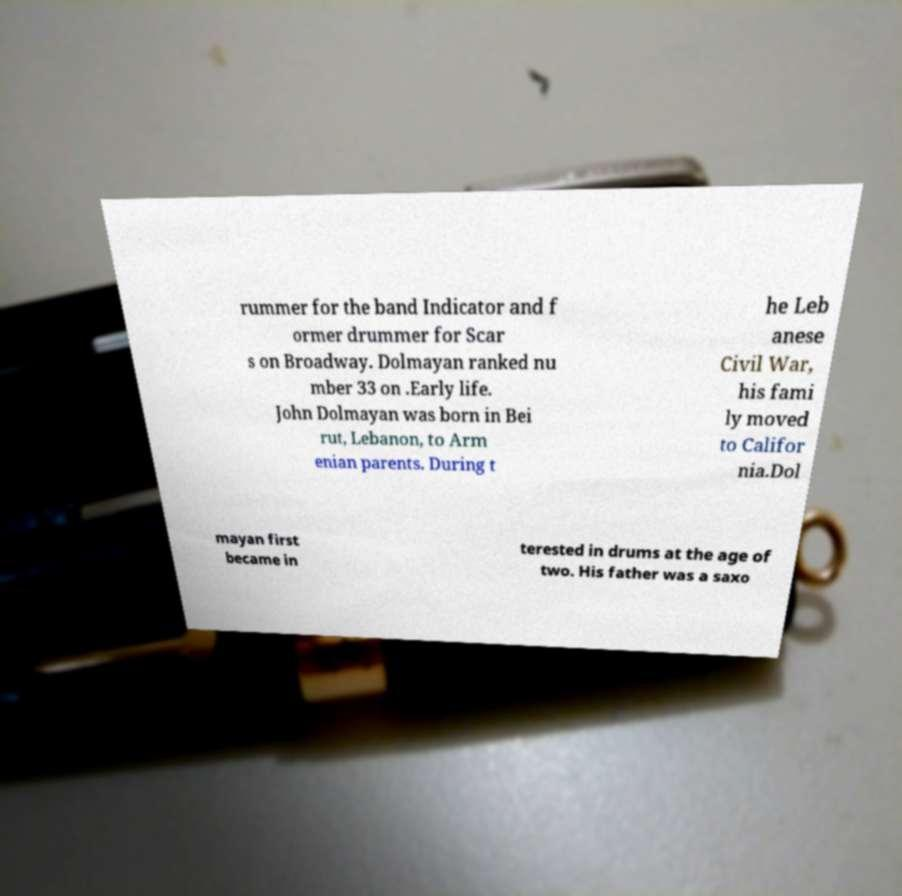Please identify and transcribe the text found in this image. rummer for the band Indicator and f ormer drummer for Scar s on Broadway. Dolmayan ranked nu mber 33 on .Early life. John Dolmayan was born in Bei rut, Lebanon, to Arm enian parents. During t he Leb anese Civil War, his fami ly moved to Califor nia.Dol mayan first became in terested in drums at the age of two. His father was a saxo 